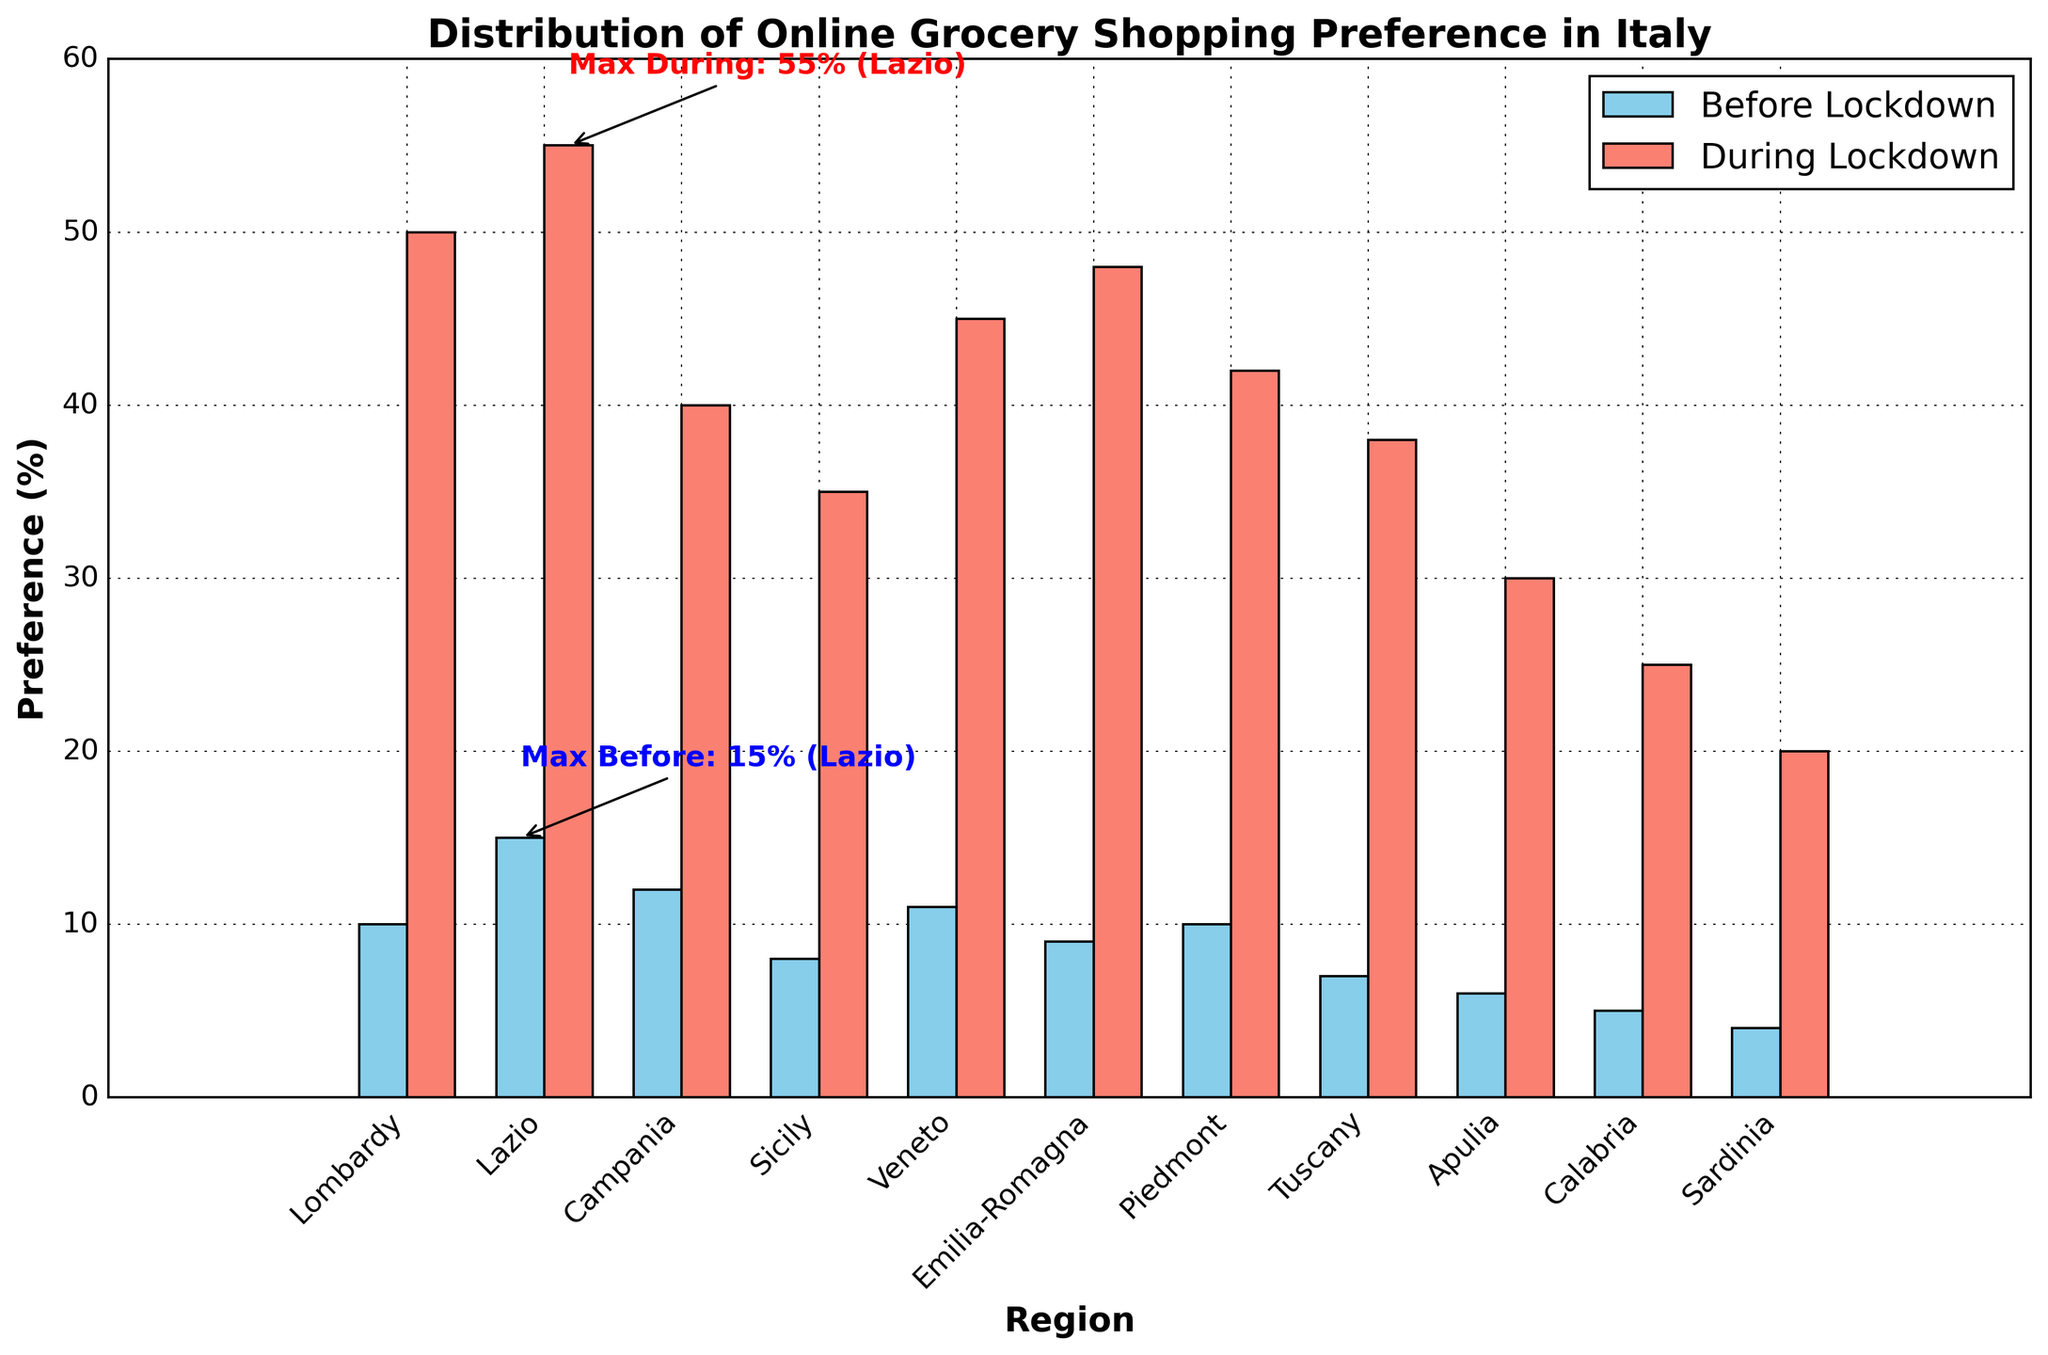Which region had the highest preference for online grocery shopping before the lockdown? To find the region with the highest preference for online grocery shopping before the lockdown, look at the values for "Preference_Before_Lockdown" and identify the region. The highest value is 15%, which belongs to Lazio.
Answer: Lazio Which region had the highest preference during the lockdown? To determine the highest preference during the lockdown, examine the "Preference_During_Lockdown" values. The highest value is 55%, which is in Lazio.
Answer: Lazio By how much did the preference for online grocery shopping increase in Lombardy during the lockdown? Find the difference between the "Preference_During_Lockdown" and the "Preference_Before_Lockdown" for Lombardy. The values are 50% and 10%, respectively. So, 50% - 10% = 40%.
Answer: 40% What is the average preference increase for online grocery shopping across all regions during the lockdown? Calculate the difference between "Preference_During_Lockdown" and "Preference_Before_Lockdown" for each region, then find the average of these differences. Increases are: 40, 40, 28, 27, 34, 39, 32, 31, 24, 20, 16. Sum these to get 331, then divide by 11 regions: 331 / 11 ≈ 30.1%.
Answer: 30.1% Visualize the difference in preference for online grocery shopping in Campania before and during the lockdown. Is the bar for "During Lockdown" at least twice the height of the bar for "Before Lockdown"? Look at the heights of the bars for Campania. "Preference_Before_Lockdown" is 12%, and "Preference_During_Lockdown" is 40%. 40% is more than triple 12%, so it's more than twice.
Answer: Yes Which region had the smallest increase in online grocery shopping preference during the lockdown? To find the smallest increase, compare the differences between "Preference_During_Lockdown" and "Preference_Before_Lockdown" for all regions. The smallest increase is 16% in Sardinia (20% - 4%).
Answer: Sardinia Which two regions had the closest increase in online grocery shopping preference during the lockdown? To identify these regions, calculate the increase for each region and then find the two closest values. The closest increases are Tuscany (31%) and Sicily (27%), with a difference of 4%.
Answer: Tuscany and Sicily Which bar color represents online grocery shopping preferences before the lockdown? To identify the color, refer to the bar chart's legend. The bars for "Before Lockdown" are shown in sky blue in the legend.
Answer: Sky blue Compare the preference for online grocery shopping in Piedmont before and during the lockdown. Did it more than triple during the lockdown? Check the values for Piedmont. "Preference_Before_Lockdown" is 10% and "Preference_During_Lockdown" is 42%. Since 42% is more than triple 10% (10% * 3 = 30%), the preference did more than triple.
Answer: Yes 